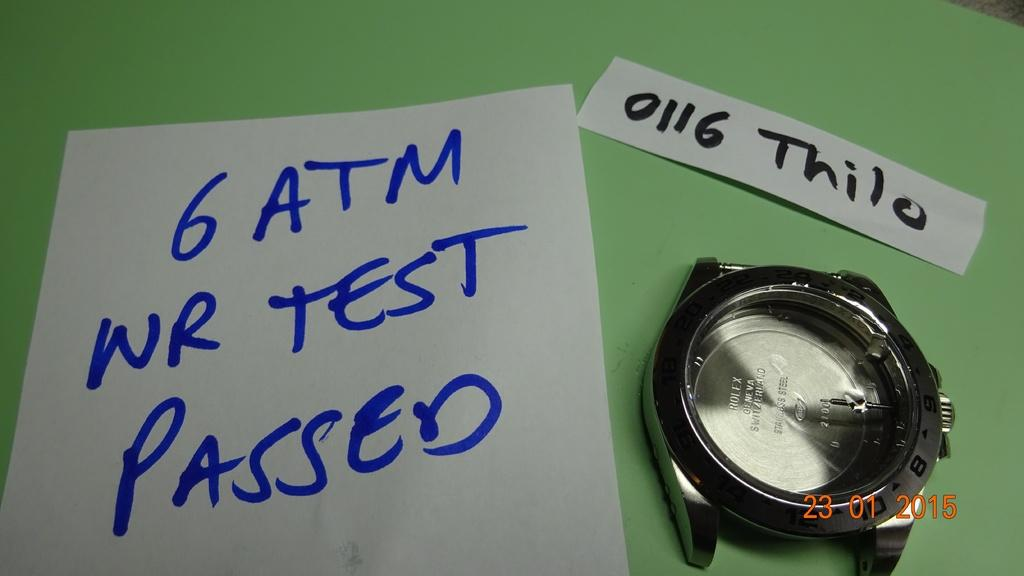<image>
Summarize the visual content of the image. A written note has the word passed in blue. 